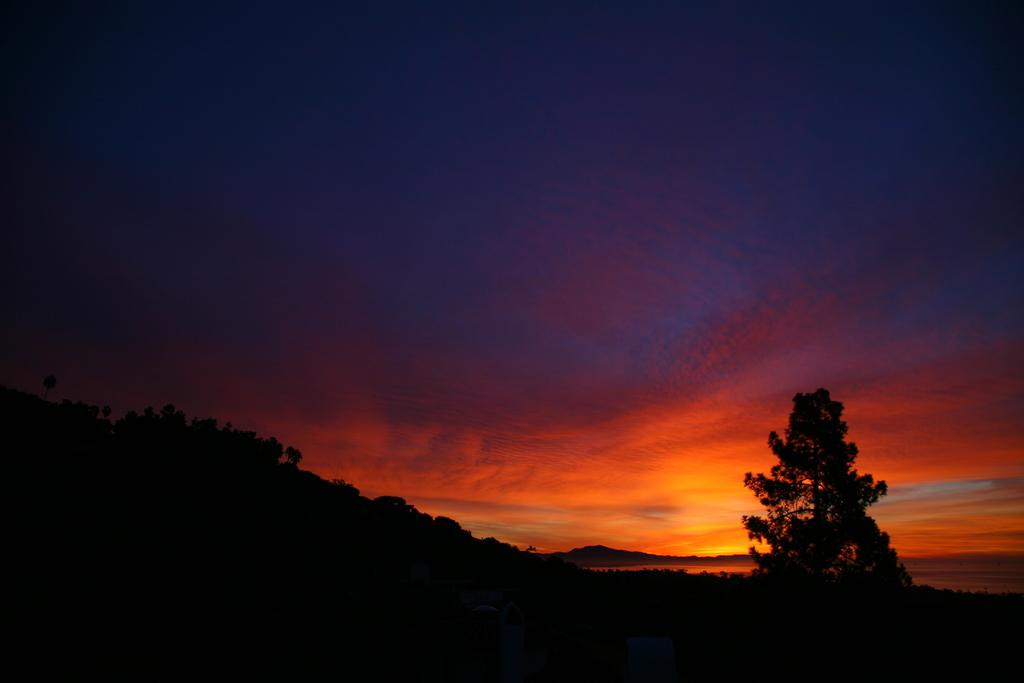What type of vegetation can be seen in the image? There are trees in the image. What geographical feature is present in the image? There is a hill in the image. What part of the natural environment is visible in the image? The sky is visible in the image. How would you describe the lighting in the image? The image appears dark. What type of jeans is the minister wearing in the image? There is no minister or jeans present in the image. How many seats can be seen in the image? There are no seats visible in the image. 